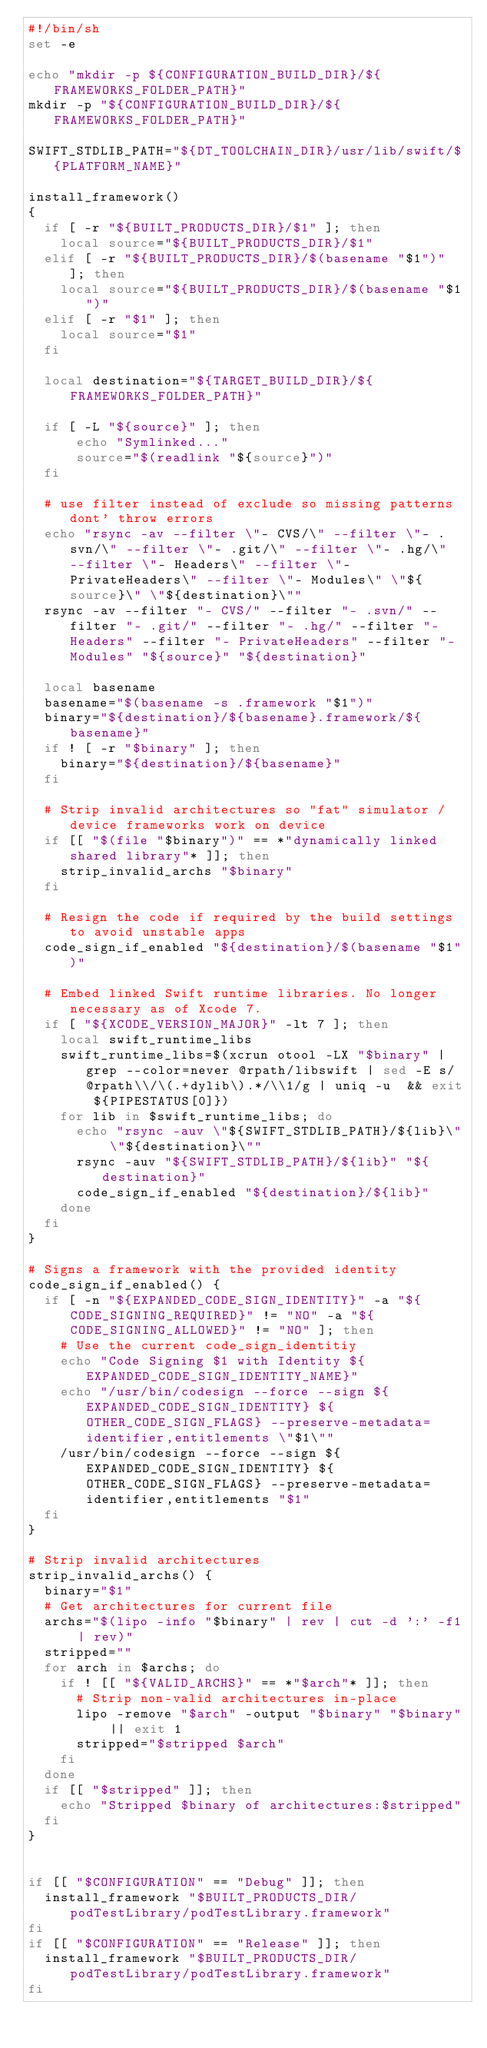<code> <loc_0><loc_0><loc_500><loc_500><_Bash_>#!/bin/sh
set -e

echo "mkdir -p ${CONFIGURATION_BUILD_DIR}/${FRAMEWORKS_FOLDER_PATH}"
mkdir -p "${CONFIGURATION_BUILD_DIR}/${FRAMEWORKS_FOLDER_PATH}"

SWIFT_STDLIB_PATH="${DT_TOOLCHAIN_DIR}/usr/lib/swift/${PLATFORM_NAME}"

install_framework()
{
  if [ -r "${BUILT_PRODUCTS_DIR}/$1" ]; then
    local source="${BUILT_PRODUCTS_DIR}/$1"
  elif [ -r "${BUILT_PRODUCTS_DIR}/$(basename "$1")" ]; then
    local source="${BUILT_PRODUCTS_DIR}/$(basename "$1")"
  elif [ -r "$1" ]; then
    local source="$1"
  fi

  local destination="${TARGET_BUILD_DIR}/${FRAMEWORKS_FOLDER_PATH}"

  if [ -L "${source}" ]; then
      echo "Symlinked..."
      source="$(readlink "${source}")"
  fi

  # use filter instead of exclude so missing patterns dont' throw errors
  echo "rsync -av --filter \"- CVS/\" --filter \"- .svn/\" --filter \"- .git/\" --filter \"- .hg/\" --filter \"- Headers\" --filter \"- PrivateHeaders\" --filter \"- Modules\" \"${source}\" \"${destination}\""
  rsync -av --filter "- CVS/" --filter "- .svn/" --filter "- .git/" --filter "- .hg/" --filter "- Headers" --filter "- PrivateHeaders" --filter "- Modules" "${source}" "${destination}"

  local basename
  basename="$(basename -s .framework "$1")"
  binary="${destination}/${basename}.framework/${basename}"
  if ! [ -r "$binary" ]; then
    binary="${destination}/${basename}"
  fi

  # Strip invalid architectures so "fat" simulator / device frameworks work on device
  if [[ "$(file "$binary")" == *"dynamically linked shared library"* ]]; then
    strip_invalid_archs "$binary"
  fi

  # Resign the code if required by the build settings to avoid unstable apps
  code_sign_if_enabled "${destination}/$(basename "$1")"

  # Embed linked Swift runtime libraries. No longer necessary as of Xcode 7.
  if [ "${XCODE_VERSION_MAJOR}" -lt 7 ]; then
    local swift_runtime_libs
    swift_runtime_libs=$(xcrun otool -LX "$binary" | grep --color=never @rpath/libswift | sed -E s/@rpath\\/\(.+dylib\).*/\\1/g | uniq -u  && exit ${PIPESTATUS[0]})
    for lib in $swift_runtime_libs; do
      echo "rsync -auv \"${SWIFT_STDLIB_PATH}/${lib}\" \"${destination}\""
      rsync -auv "${SWIFT_STDLIB_PATH}/${lib}" "${destination}"
      code_sign_if_enabled "${destination}/${lib}"
    done
  fi
}

# Signs a framework with the provided identity
code_sign_if_enabled() {
  if [ -n "${EXPANDED_CODE_SIGN_IDENTITY}" -a "${CODE_SIGNING_REQUIRED}" != "NO" -a "${CODE_SIGNING_ALLOWED}" != "NO" ]; then
    # Use the current code_sign_identitiy
    echo "Code Signing $1 with Identity ${EXPANDED_CODE_SIGN_IDENTITY_NAME}"
    echo "/usr/bin/codesign --force --sign ${EXPANDED_CODE_SIGN_IDENTITY} ${OTHER_CODE_SIGN_FLAGS} --preserve-metadata=identifier,entitlements \"$1\""
    /usr/bin/codesign --force --sign ${EXPANDED_CODE_SIGN_IDENTITY} ${OTHER_CODE_SIGN_FLAGS} --preserve-metadata=identifier,entitlements "$1"
  fi
}

# Strip invalid architectures
strip_invalid_archs() {
  binary="$1"
  # Get architectures for current file
  archs="$(lipo -info "$binary" | rev | cut -d ':' -f1 | rev)"
  stripped=""
  for arch in $archs; do
    if ! [[ "${VALID_ARCHS}" == *"$arch"* ]]; then
      # Strip non-valid architectures in-place
      lipo -remove "$arch" -output "$binary" "$binary" || exit 1
      stripped="$stripped $arch"
    fi
  done
  if [[ "$stripped" ]]; then
    echo "Stripped $binary of architectures:$stripped"
  fi
}


if [[ "$CONFIGURATION" == "Debug" ]]; then
  install_framework "$BUILT_PRODUCTS_DIR/podTestLibrary/podTestLibrary.framework"
fi
if [[ "$CONFIGURATION" == "Release" ]]; then
  install_framework "$BUILT_PRODUCTS_DIR/podTestLibrary/podTestLibrary.framework"
fi
</code> 